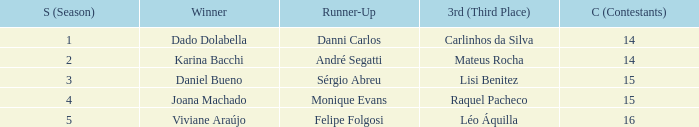How many contestants were there when the runner-up was Sérgio Abreu?  15.0. 